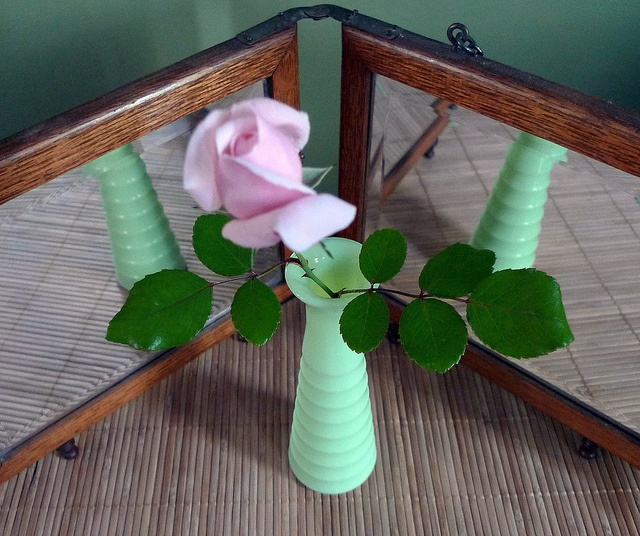Describe the objects in this image and their specific colors. I can see a vase in teal, aquamarine, and turquoise tones in this image. 